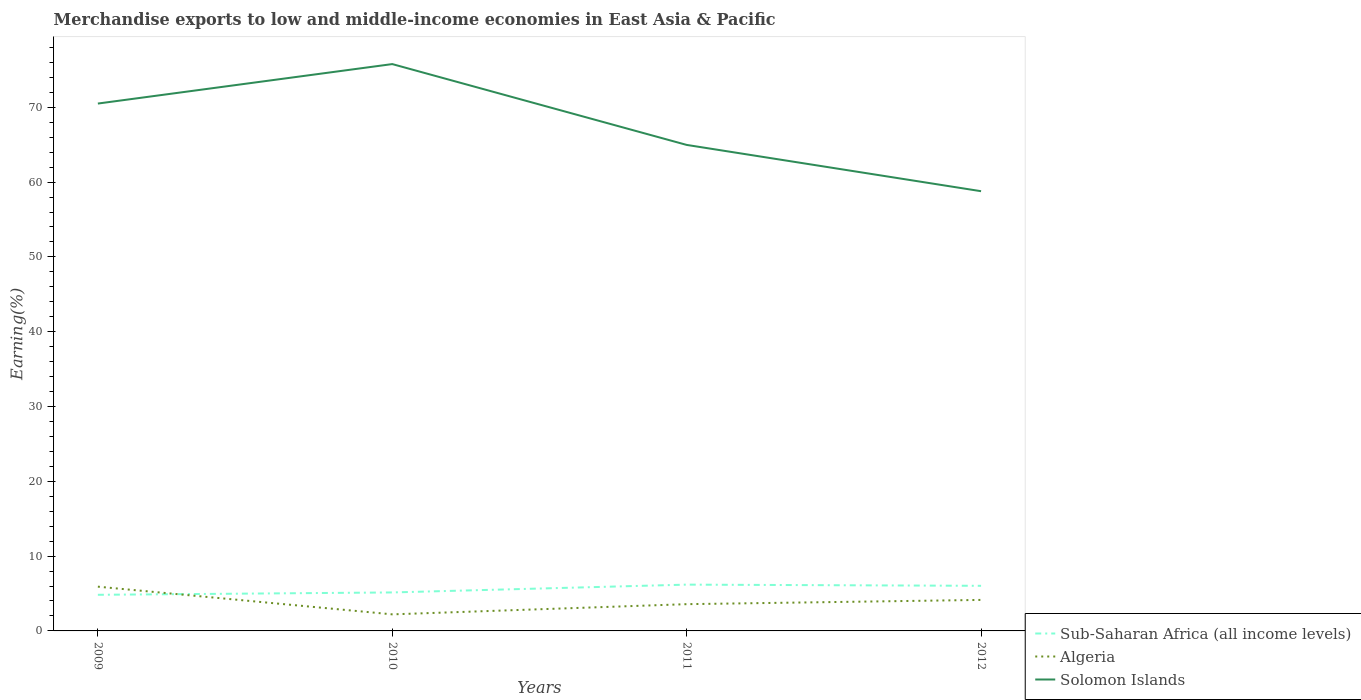Is the number of lines equal to the number of legend labels?
Your answer should be very brief. Yes. Across all years, what is the maximum percentage of amount earned from merchandise exports in Algeria?
Provide a succinct answer. 2.21. In which year was the percentage of amount earned from merchandise exports in Algeria maximum?
Offer a very short reply. 2010. What is the total percentage of amount earned from merchandise exports in Solomon Islands in the graph?
Provide a short and direct response. 5.53. What is the difference between the highest and the second highest percentage of amount earned from merchandise exports in Sub-Saharan Africa (all income levels)?
Your answer should be compact. 1.36. Is the percentage of amount earned from merchandise exports in Sub-Saharan Africa (all income levels) strictly greater than the percentage of amount earned from merchandise exports in Solomon Islands over the years?
Provide a succinct answer. Yes. What is the difference between two consecutive major ticks on the Y-axis?
Provide a succinct answer. 10. Are the values on the major ticks of Y-axis written in scientific E-notation?
Your answer should be very brief. No. How are the legend labels stacked?
Make the answer very short. Vertical. What is the title of the graph?
Your answer should be very brief. Merchandise exports to low and middle-income economies in East Asia & Pacific. Does "Mexico" appear as one of the legend labels in the graph?
Ensure brevity in your answer.  No. What is the label or title of the Y-axis?
Your answer should be very brief. Earning(%). What is the Earning(%) of Sub-Saharan Africa (all income levels) in 2009?
Offer a very short reply. 4.83. What is the Earning(%) in Algeria in 2009?
Provide a short and direct response. 5.92. What is the Earning(%) in Solomon Islands in 2009?
Your answer should be compact. 70.5. What is the Earning(%) in Sub-Saharan Africa (all income levels) in 2010?
Offer a very short reply. 5.14. What is the Earning(%) in Algeria in 2010?
Your response must be concise. 2.21. What is the Earning(%) of Solomon Islands in 2010?
Make the answer very short. 75.78. What is the Earning(%) in Sub-Saharan Africa (all income levels) in 2011?
Keep it short and to the point. 6.19. What is the Earning(%) of Algeria in 2011?
Make the answer very short. 3.58. What is the Earning(%) of Solomon Islands in 2011?
Ensure brevity in your answer.  64.97. What is the Earning(%) of Sub-Saharan Africa (all income levels) in 2012?
Make the answer very short. 6.03. What is the Earning(%) of Algeria in 2012?
Offer a terse response. 4.15. What is the Earning(%) in Solomon Islands in 2012?
Your answer should be very brief. 58.78. Across all years, what is the maximum Earning(%) of Sub-Saharan Africa (all income levels)?
Provide a succinct answer. 6.19. Across all years, what is the maximum Earning(%) of Algeria?
Your answer should be very brief. 5.92. Across all years, what is the maximum Earning(%) of Solomon Islands?
Your response must be concise. 75.78. Across all years, what is the minimum Earning(%) of Sub-Saharan Africa (all income levels)?
Make the answer very short. 4.83. Across all years, what is the minimum Earning(%) in Algeria?
Offer a terse response. 2.21. Across all years, what is the minimum Earning(%) in Solomon Islands?
Ensure brevity in your answer.  58.78. What is the total Earning(%) of Sub-Saharan Africa (all income levels) in the graph?
Offer a very short reply. 22.19. What is the total Earning(%) in Algeria in the graph?
Your answer should be very brief. 15.85. What is the total Earning(%) in Solomon Islands in the graph?
Your response must be concise. 270.03. What is the difference between the Earning(%) in Sub-Saharan Africa (all income levels) in 2009 and that in 2010?
Provide a short and direct response. -0.32. What is the difference between the Earning(%) in Algeria in 2009 and that in 2010?
Provide a succinct answer. 3.7. What is the difference between the Earning(%) in Solomon Islands in 2009 and that in 2010?
Offer a very short reply. -5.28. What is the difference between the Earning(%) in Sub-Saharan Africa (all income levels) in 2009 and that in 2011?
Keep it short and to the point. -1.36. What is the difference between the Earning(%) in Algeria in 2009 and that in 2011?
Your answer should be compact. 2.34. What is the difference between the Earning(%) of Solomon Islands in 2009 and that in 2011?
Offer a terse response. 5.53. What is the difference between the Earning(%) of Sub-Saharan Africa (all income levels) in 2009 and that in 2012?
Your answer should be very brief. -1.2. What is the difference between the Earning(%) in Algeria in 2009 and that in 2012?
Ensure brevity in your answer.  1.77. What is the difference between the Earning(%) in Solomon Islands in 2009 and that in 2012?
Ensure brevity in your answer.  11.72. What is the difference between the Earning(%) in Sub-Saharan Africa (all income levels) in 2010 and that in 2011?
Your answer should be very brief. -1.05. What is the difference between the Earning(%) of Algeria in 2010 and that in 2011?
Your answer should be compact. -1.36. What is the difference between the Earning(%) in Solomon Islands in 2010 and that in 2011?
Offer a terse response. 10.81. What is the difference between the Earning(%) of Sub-Saharan Africa (all income levels) in 2010 and that in 2012?
Make the answer very short. -0.89. What is the difference between the Earning(%) of Algeria in 2010 and that in 2012?
Provide a succinct answer. -1.93. What is the difference between the Earning(%) of Solomon Islands in 2010 and that in 2012?
Provide a succinct answer. 16.99. What is the difference between the Earning(%) in Sub-Saharan Africa (all income levels) in 2011 and that in 2012?
Give a very brief answer. 0.16. What is the difference between the Earning(%) in Algeria in 2011 and that in 2012?
Your answer should be compact. -0.57. What is the difference between the Earning(%) in Solomon Islands in 2011 and that in 2012?
Keep it short and to the point. 6.19. What is the difference between the Earning(%) of Sub-Saharan Africa (all income levels) in 2009 and the Earning(%) of Algeria in 2010?
Offer a very short reply. 2.61. What is the difference between the Earning(%) in Sub-Saharan Africa (all income levels) in 2009 and the Earning(%) in Solomon Islands in 2010?
Offer a terse response. -70.95. What is the difference between the Earning(%) of Algeria in 2009 and the Earning(%) of Solomon Islands in 2010?
Offer a terse response. -69.86. What is the difference between the Earning(%) in Sub-Saharan Africa (all income levels) in 2009 and the Earning(%) in Algeria in 2011?
Make the answer very short. 1.25. What is the difference between the Earning(%) in Sub-Saharan Africa (all income levels) in 2009 and the Earning(%) in Solomon Islands in 2011?
Provide a succinct answer. -60.14. What is the difference between the Earning(%) of Algeria in 2009 and the Earning(%) of Solomon Islands in 2011?
Offer a terse response. -59.05. What is the difference between the Earning(%) in Sub-Saharan Africa (all income levels) in 2009 and the Earning(%) in Algeria in 2012?
Provide a short and direct response. 0.68. What is the difference between the Earning(%) of Sub-Saharan Africa (all income levels) in 2009 and the Earning(%) of Solomon Islands in 2012?
Your answer should be very brief. -53.95. What is the difference between the Earning(%) of Algeria in 2009 and the Earning(%) of Solomon Islands in 2012?
Provide a succinct answer. -52.87. What is the difference between the Earning(%) of Sub-Saharan Africa (all income levels) in 2010 and the Earning(%) of Algeria in 2011?
Your answer should be very brief. 1.57. What is the difference between the Earning(%) of Sub-Saharan Africa (all income levels) in 2010 and the Earning(%) of Solomon Islands in 2011?
Your answer should be very brief. -59.83. What is the difference between the Earning(%) of Algeria in 2010 and the Earning(%) of Solomon Islands in 2011?
Keep it short and to the point. -62.76. What is the difference between the Earning(%) in Sub-Saharan Africa (all income levels) in 2010 and the Earning(%) in Solomon Islands in 2012?
Your response must be concise. -53.64. What is the difference between the Earning(%) of Algeria in 2010 and the Earning(%) of Solomon Islands in 2012?
Offer a very short reply. -56.57. What is the difference between the Earning(%) in Sub-Saharan Africa (all income levels) in 2011 and the Earning(%) in Algeria in 2012?
Your answer should be very brief. 2.04. What is the difference between the Earning(%) of Sub-Saharan Africa (all income levels) in 2011 and the Earning(%) of Solomon Islands in 2012?
Offer a very short reply. -52.59. What is the difference between the Earning(%) in Algeria in 2011 and the Earning(%) in Solomon Islands in 2012?
Your answer should be compact. -55.21. What is the average Earning(%) in Sub-Saharan Africa (all income levels) per year?
Your response must be concise. 5.55. What is the average Earning(%) in Algeria per year?
Make the answer very short. 3.96. What is the average Earning(%) of Solomon Islands per year?
Your answer should be very brief. 67.51. In the year 2009, what is the difference between the Earning(%) of Sub-Saharan Africa (all income levels) and Earning(%) of Algeria?
Your answer should be very brief. -1.09. In the year 2009, what is the difference between the Earning(%) of Sub-Saharan Africa (all income levels) and Earning(%) of Solomon Islands?
Your response must be concise. -65.67. In the year 2009, what is the difference between the Earning(%) in Algeria and Earning(%) in Solomon Islands?
Your answer should be very brief. -64.58. In the year 2010, what is the difference between the Earning(%) in Sub-Saharan Africa (all income levels) and Earning(%) in Algeria?
Your answer should be compact. 2.93. In the year 2010, what is the difference between the Earning(%) in Sub-Saharan Africa (all income levels) and Earning(%) in Solomon Islands?
Make the answer very short. -70.63. In the year 2010, what is the difference between the Earning(%) in Algeria and Earning(%) in Solomon Islands?
Provide a succinct answer. -73.56. In the year 2011, what is the difference between the Earning(%) of Sub-Saharan Africa (all income levels) and Earning(%) of Algeria?
Make the answer very short. 2.61. In the year 2011, what is the difference between the Earning(%) of Sub-Saharan Africa (all income levels) and Earning(%) of Solomon Islands?
Ensure brevity in your answer.  -58.78. In the year 2011, what is the difference between the Earning(%) in Algeria and Earning(%) in Solomon Islands?
Ensure brevity in your answer.  -61.39. In the year 2012, what is the difference between the Earning(%) of Sub-Saharan Africa (all income levels) and Earning(%) of Algeria?
Offer a very short reply. 1.88. In the year 2012, what is the difference between the Earning(%) in Sub-Saharan Africa (all income levels) and Earning(%) in Solomon Islands?
Your answer should be very brief. -52.75. In the year 2012, what is the difference between the Earning(%) of Algeria and Earning(%) of Solomon Islands?
Offer a terse response. -54.64. What is the ratio of the Earning(%) of Sub-Saharan Africa (all income levels) in 2009 to that in 2010?
Provide a succinct answer. 0.94. What is the ratio of the Earning(%) of Algeria in 2009 to that in 2010?
Make the answer very short. 2.67. What is the ratio of the Earning(%) in Solomon Islands in 2009 to that in 2010?
Your answer should be very brief. 0.93. What is the ratio of the Earning(%) in Sub-Saharan Africa (all income levels) in 2009 to that in 2011?
Your answer should be very brief. 0.78. What is the ratio of the Earning(%) in Algeria in 2009 to that in 2011?
Ensure brevity in your answer.  1.65. What is the ratio of the Earning(%) in Solomon Islands in 2009 to that in 2011?
Your answer should be compact. 1.09. What is the ratio of the Earning(%) of Sub-Saharan Africa (all income levels) in 2009 to that in 2012?
Provide a succinct answer. 0.8. What is the ratio of the Earning(%) in Algeria in 2009 to that in 2012?
Offer a very short reply. 1.43. What is the ratio of the Earning(%) in Solomon Islands in 2009 to that in 2012?
Keep it short and to the point. 1.2. What is the ratio of the Earning(%) of Sub-Saharan Africa (all income levels) in 2010 to that in 2011?
Provide a succinct answer. 0.83. What is the ratio of the Earning(%) of Algeria in 2010 to that in 2011?
Ensure brevity in your answer.  0.62. What is the ratio of the Earning(%) of Solomon Islands in 2010 to that in 2011?
Provide a short and direct response. 1.17. What is the ratio of the Earning(%) in Sub-Saharan Africa (all income levels) in 2010 to that in 2012?
Ensure brevity in your answer.  0.85. What is the ratio of the Earning(%) in Algeria in 2010 to that in 2012?
Offer a very short reply. 0.53. What is the ratio of the Earning(%) in Solomon Islands in 2010 to that in 2012?
Your answer should be very brief. 1.29. What is the ratio of the Earning(%) in Sub-Saharan Africa (all income levels) in 2011 to that in 2012?
Offer a terse response. 1.03. What is the ratio of the Earning(%) in Algeria in 2011 to that in 2012?
Make the answer very short. 0.86. What is the ratio of the Earning(%) in Solomon Islands in 2011 to that in 2012?
Ensure brevity in your answer.  1.11. What is the difference between the highest and the second highest Earning(%) of Sub-Saharan Africa (all income levels)?
Keep it short and to the point. 0.16. What is the difference between the highest and the second highest Earning(%) of Algeria?
Make the answer very short. 1.77. What is the difference between the highest and the second highest Earning(%) of Solomon Islands?
Keep it short and to the point. 5.28. What is the difference between the highest and the lowest Earning(%) of Sub-Saharan Africa (all income levels)?
Provide a succinct answer. 1.36. What is the difference between the highest and the lowest Earning(%) in Algeria?
Give a very brief answer. 3.7. What is the difference between the highest and the lowest Earning(%) of Solomon Islands?
Your answer should be very brief. 16.99. 